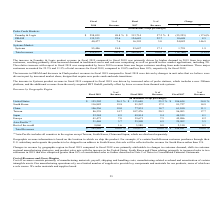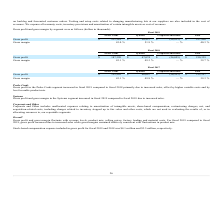According to Formfactor's financial document, What led to increase in Gross profit and gross margin in the Systems segment in fiscal 2019 compared to fiscal 2018? Gross profit and gross margin in the Systems segment increased in fiscal 2019 compared to fiscal 2018 due to increased sales.. The document states: "Systems Gross profit and gross margin in the Systems segment increased in fiscal 2019 compared to fiscal 2018 due to increased sales...." Also, can you calculate: What is the increase/ (decrease) in Gross profit of Probe Cards from fiscal 2019 to 2018? Based on the calculation: 211,382-187,320, the result is 24062 (in thousands). This is based on the information: "Gross profit $ 211,382 $ 50,927 $ (24,813) $ 237,496 Gross profit $ 187,320 $ 47,074 $ (24,055) $ 210,339..." The key data points involved are: 187,320, 211,382. Also, can you calculate: What is the increase/ (decrease) in Gross profit of Systems from fiscal 2019 to 2018? Based on the calculation: 50,927-47,074, the result is 3853 (in thousands). This is based on the information: "Gross profit $ 187,320 $ 47,074 $ (24,055) $ 210,339 Gross profit $ 211,382 $ 50,927 $ (24,813) $ 237,496..." The key data points involved are: 47,074, 50,927. Additionally, For which revenue segment was Gross margin under 50.0% in 2019? The document shows two values: Probe Cards and Corporate and Other. Locate and analyze gross margin in row 4. From the document: "Probe Cards Systems Corporate and Other Total Probe Cards Systems Corporate and Other Total..." Also, What does cost of revenues include? onsists primarily of manufacturing materials, payroll, shipping and handling costs, manufacturing-related overhead and amortization of certain intangible assets. The document states: "t of Revenues and Gross Margins Cost of revenues consists primarily of manufacturing materials, payroll, shipping and handling costs, manufacturing-re..." Also, What was the Gross Profit in 2019 for Probe Cards and Systems? The document shows two values: 43.0 and 51.9 (percentage). From the document: "Gross margin 43.0 % 51.9 % — % 40.3 % Gross margin 43.0 % 51.9 % — % 40.3 %..." 